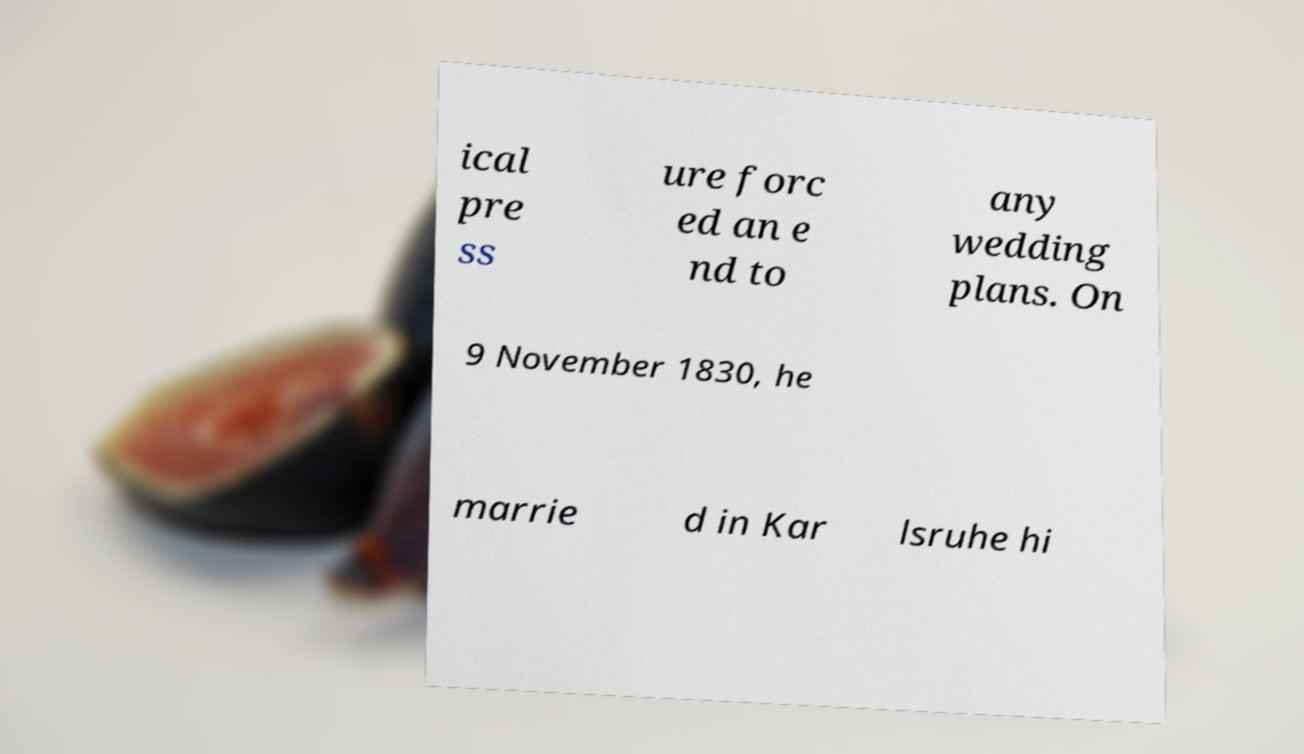Please identify and transcribe the text found in this image. ical pre ss ure forc ed an e nd to any wedding plans. On 9 November 1830, he marrie d in Kar lsruhe hi 